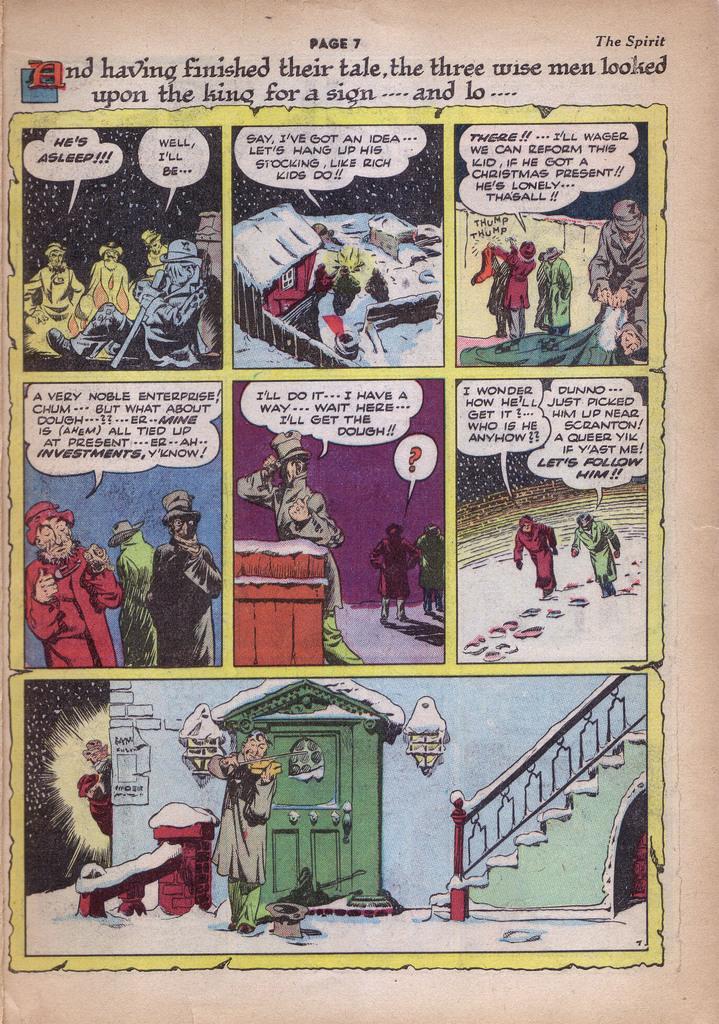What page is this?
Your answer should be very brief. 7. What is the third word on the text at the top?
Give a very brief answer. Finished. 